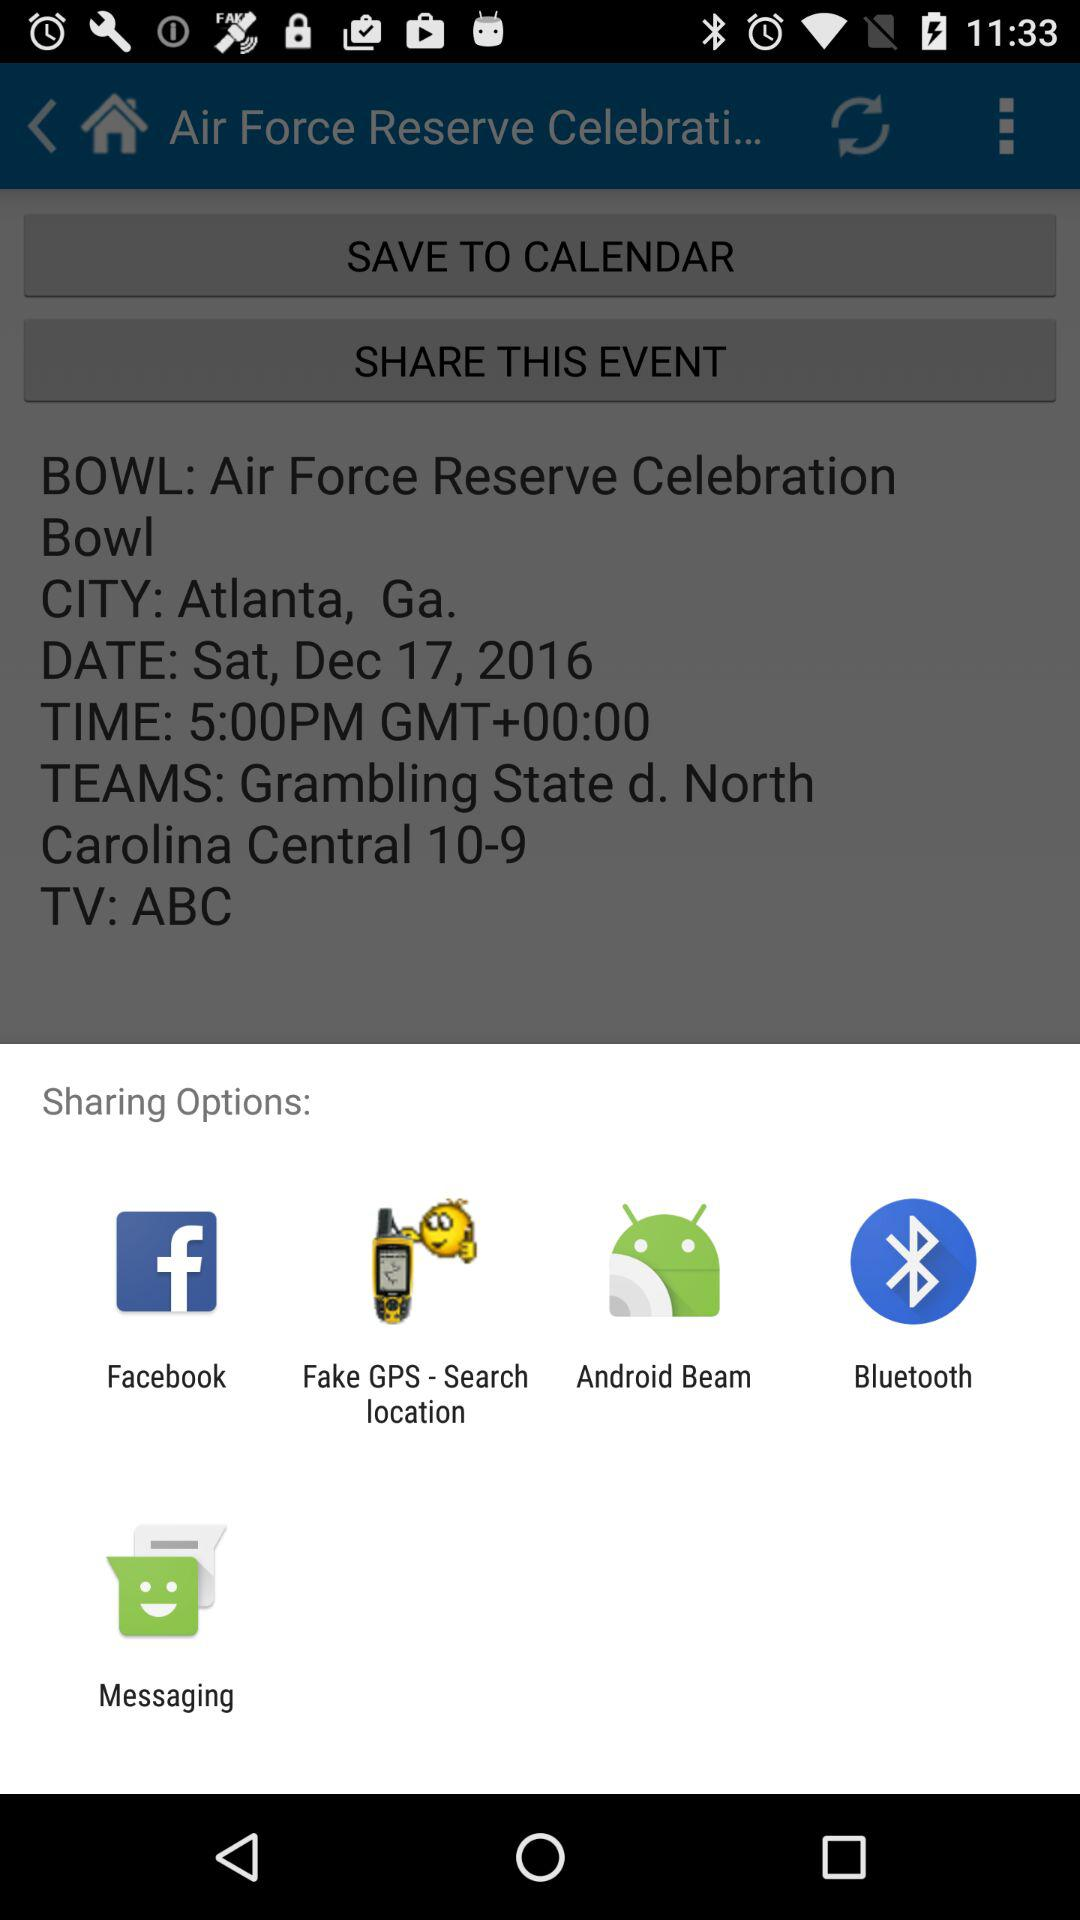What is the event name? The event name is "Air Force Reserve Celebration Bowl". 